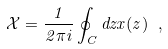<formula> <loc_0><loc_0><loc_500><loc_500>\mathcal { X } = \frac { 1 } { 2 \pi i } \oint _ { C } d z x ( z ) \ ,</formula> 